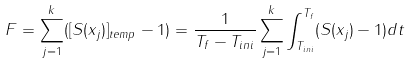<formula> <loc_0><loc_0><loc_500><loc_500>F = \sum _ { j = 1 } ^ { k } ( [ S ( x _ { j } ) ] _ { t e m p } - 1 ) = \frac { 1 } { T _ { f } - T _ { i n i } } \sum _ { j = 1 } ^ { k } \int _ { T _ { i n i } } ^ { T _ { f } } ( S ( x _ { j } ) - 1 ) d t</formula> 